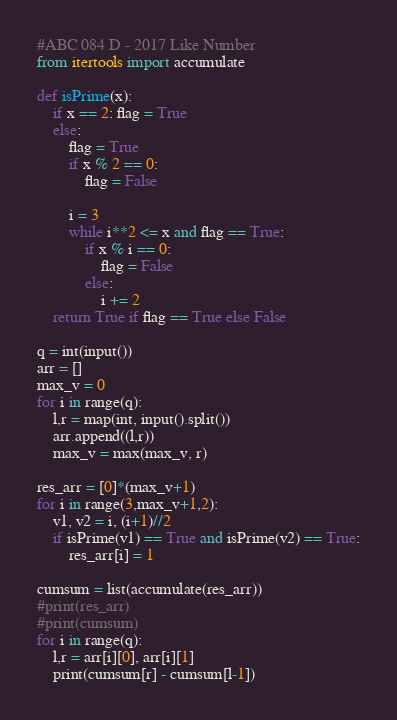Convert code to text. <code><loc_0><loc_0><loc_500><loc_500><_Python_>#ABC 084 D - 2017 Like Number
from itertools import accumulate

def isPrime(x):
    if x == 2: flag = True
    else:
        flag = True
        if x % 2 == 0:
            flag = False
        
        i = 3
        while i**2 <= x and flag == True:
            if x % i == 0:
                flag = False
            else:
                i += 2
    return True if flag == True else False

q = int(input())
arr = []
max_v = 0
for i in range(q):
    l,r = map(int, input().split())
    arr.append((l,r))
    max_v = max(max_v, r)

res_arr = [0]*(max_v+1)
for i in range(3,max_v+1,2):
    v1, v2 = i, (i+1)//2
    if isPrime(v1) == True and isPrime(v2) == True:
        res_arr[i] = 1

cumsum = list(accumulate(res_arr))
#print(res_arr)
#print(cumsum)
for i in range(q):
    l,r = arr[i][0], arr[i][1]
    print(cumsum[r] - cumsum[l-1])</code> 